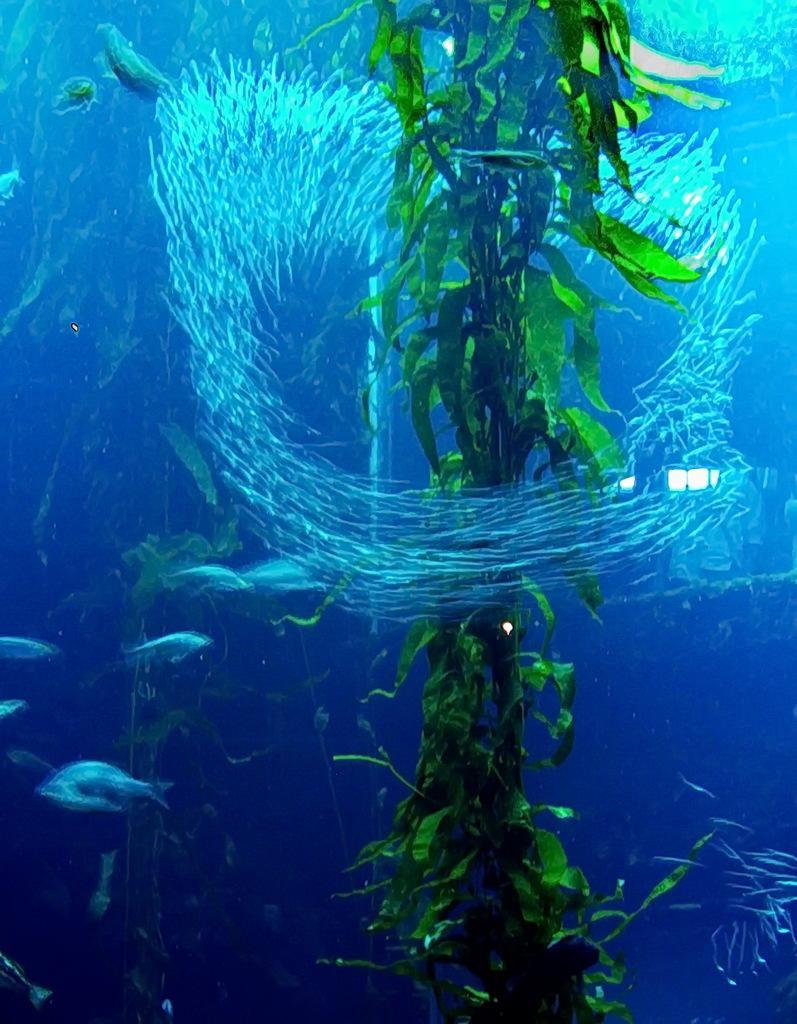Please provide a concise description of this image. This picture describes about underwater environment, in this we can find few fishes and plants. 